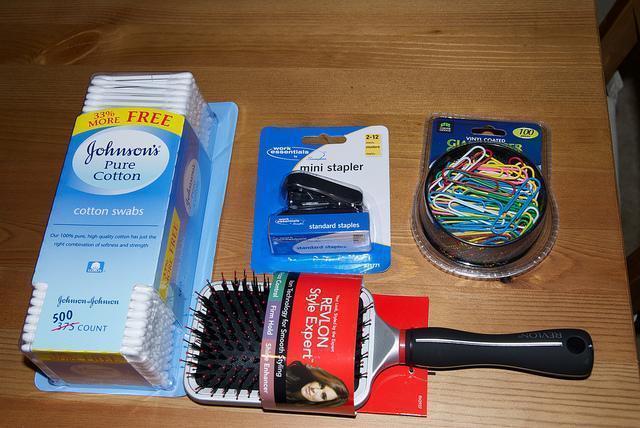How many people can be seen?
Give a very brief answer. 0. 